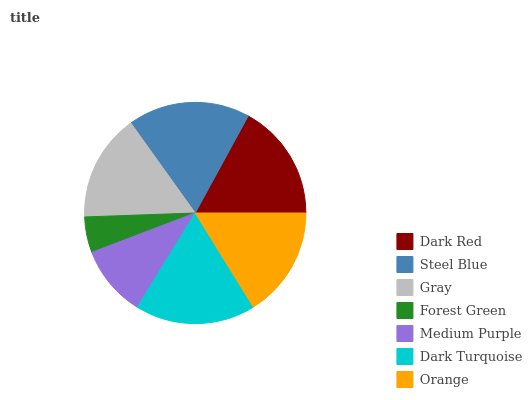Is Forest Green the minimum?
Answer yes or no. Yes. Is Steel Blue the maximum?
Answer yes or no. Yes. Is Gray the minimum?
Answer yes or no. No. Is Gray the maximum?
Answer yes or no. No. Is Steel Blue greater than Gray?
Answer yes or no. Yes. Is Gray less than Steel Blue?
Answer yes or no. Yes. Is Gray greater than Steel Blue?
Answer yes or no. No. Is Steel Blue less than Gray?
Answer yes or no. No. Is Orange the high median?
Answer yes or no. Yes. Is Orange the low median?
Answer yes or no. Yes. Is Medium Purple the high median?
Answer yes or no. No. Is Forest Green the low median?
Answer yes or no. No. 